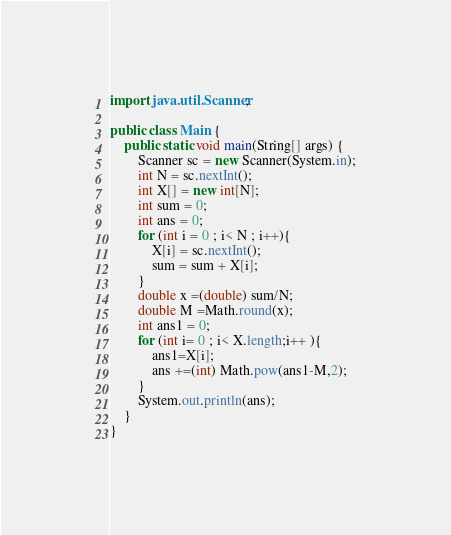<code> <loc_0><loc_0><loc_500><loc_500><_Java_>import java.util.Scanner;

public class Main {
    public static void main(String[] args) {
        Scanner sc = new Scanner(System.in);
        int N = sc.nextInt();
        int X[] = new int[N];
        int sum = 0;
        int ans = 0;
        for (int i = 0 ; i< N ; i++){
            X[i] = sc.nextInt();
            sum = sum + X[i];
        }
        double x =(double) sum/N;
        double M =Math.round(x);
        int ans1 = 0;
        for (int i= 0 ; i< X.length;i++ ){
            ans1=X[i];
            ans +=(int) Math.pow(ans1-M,2);
        }
        System.out.println(ans);
    }
}
</code> 